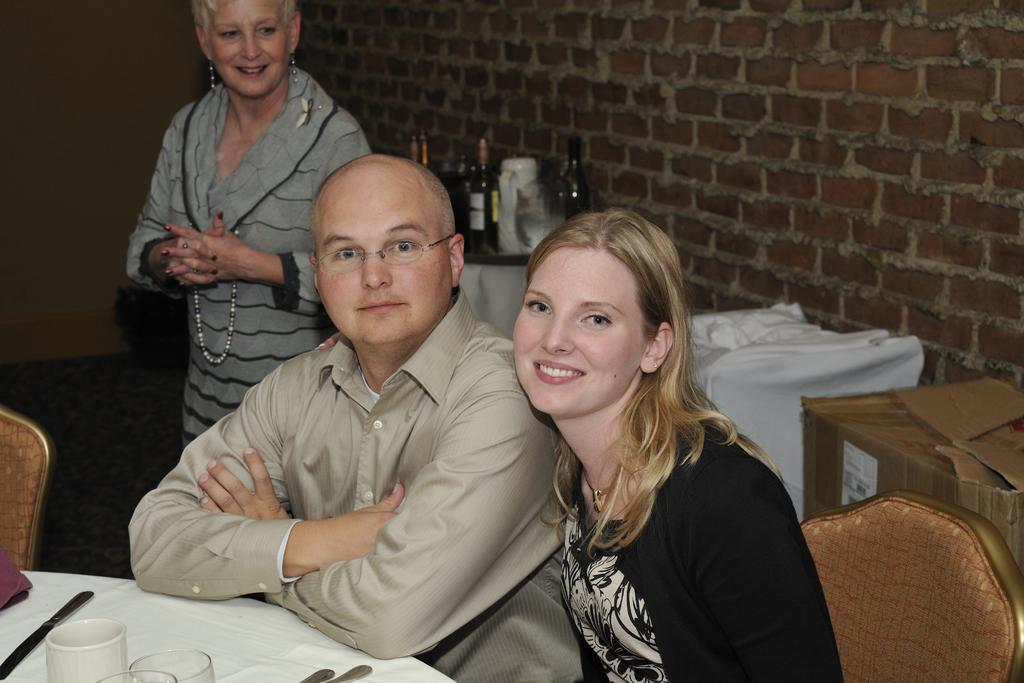How many people are present in the image? There are three people in the image. What are the positions of the people in the image? Two of the people are sitting on a sofa, and one person is standing. What type of window can be seen in the image? There is no window present in the image; it features three people, two sitting on a sofa and one standing. How tall are the giants in the image? There are no giants present in the image; it features three people, two sitting and one standing. 